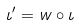<formula> <loc_0><loc_0><loc_500><loc_500>\iota ^ { \prime } = w \circ \iota</formula> 